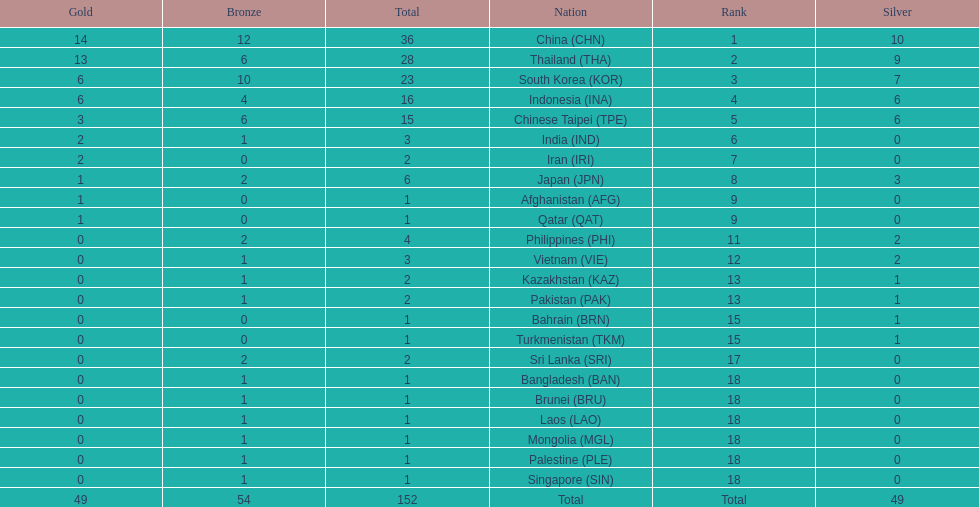Did the philippines or kazakhstan have a higher number of total medals? Philippines. 